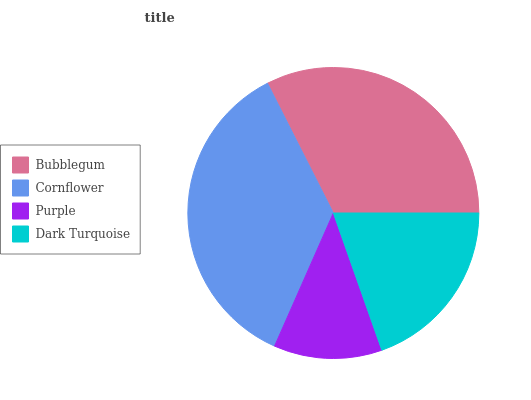Is Purple the minimum?
Answer yes or no. Yes. Is Cornflower the maximum?
Answer yes or no. Yes. Is Cornflower the minimum?
Answer yes or no. No. Is Purple the maximum?
Answer yes or no. No. Is Cornflower greater than Purple?
Answer yes or no. Yes. Is Purple less than Cornflower?
Answer yes or no. Yes. Is Purple greater than Cornflower?
Answer yes or no. No. Is Cornflower less than Purple?
Answer yes or no. No. Is Bubblegum the high median?
Answer yes or no. Yes. Is Dark Turquoise the low median?
Answer yes or no. Yes. Is Dark Turquoise the high median?
Answer yes or no. No. Is Cornflower the low median?
Answer yes or no. No. 